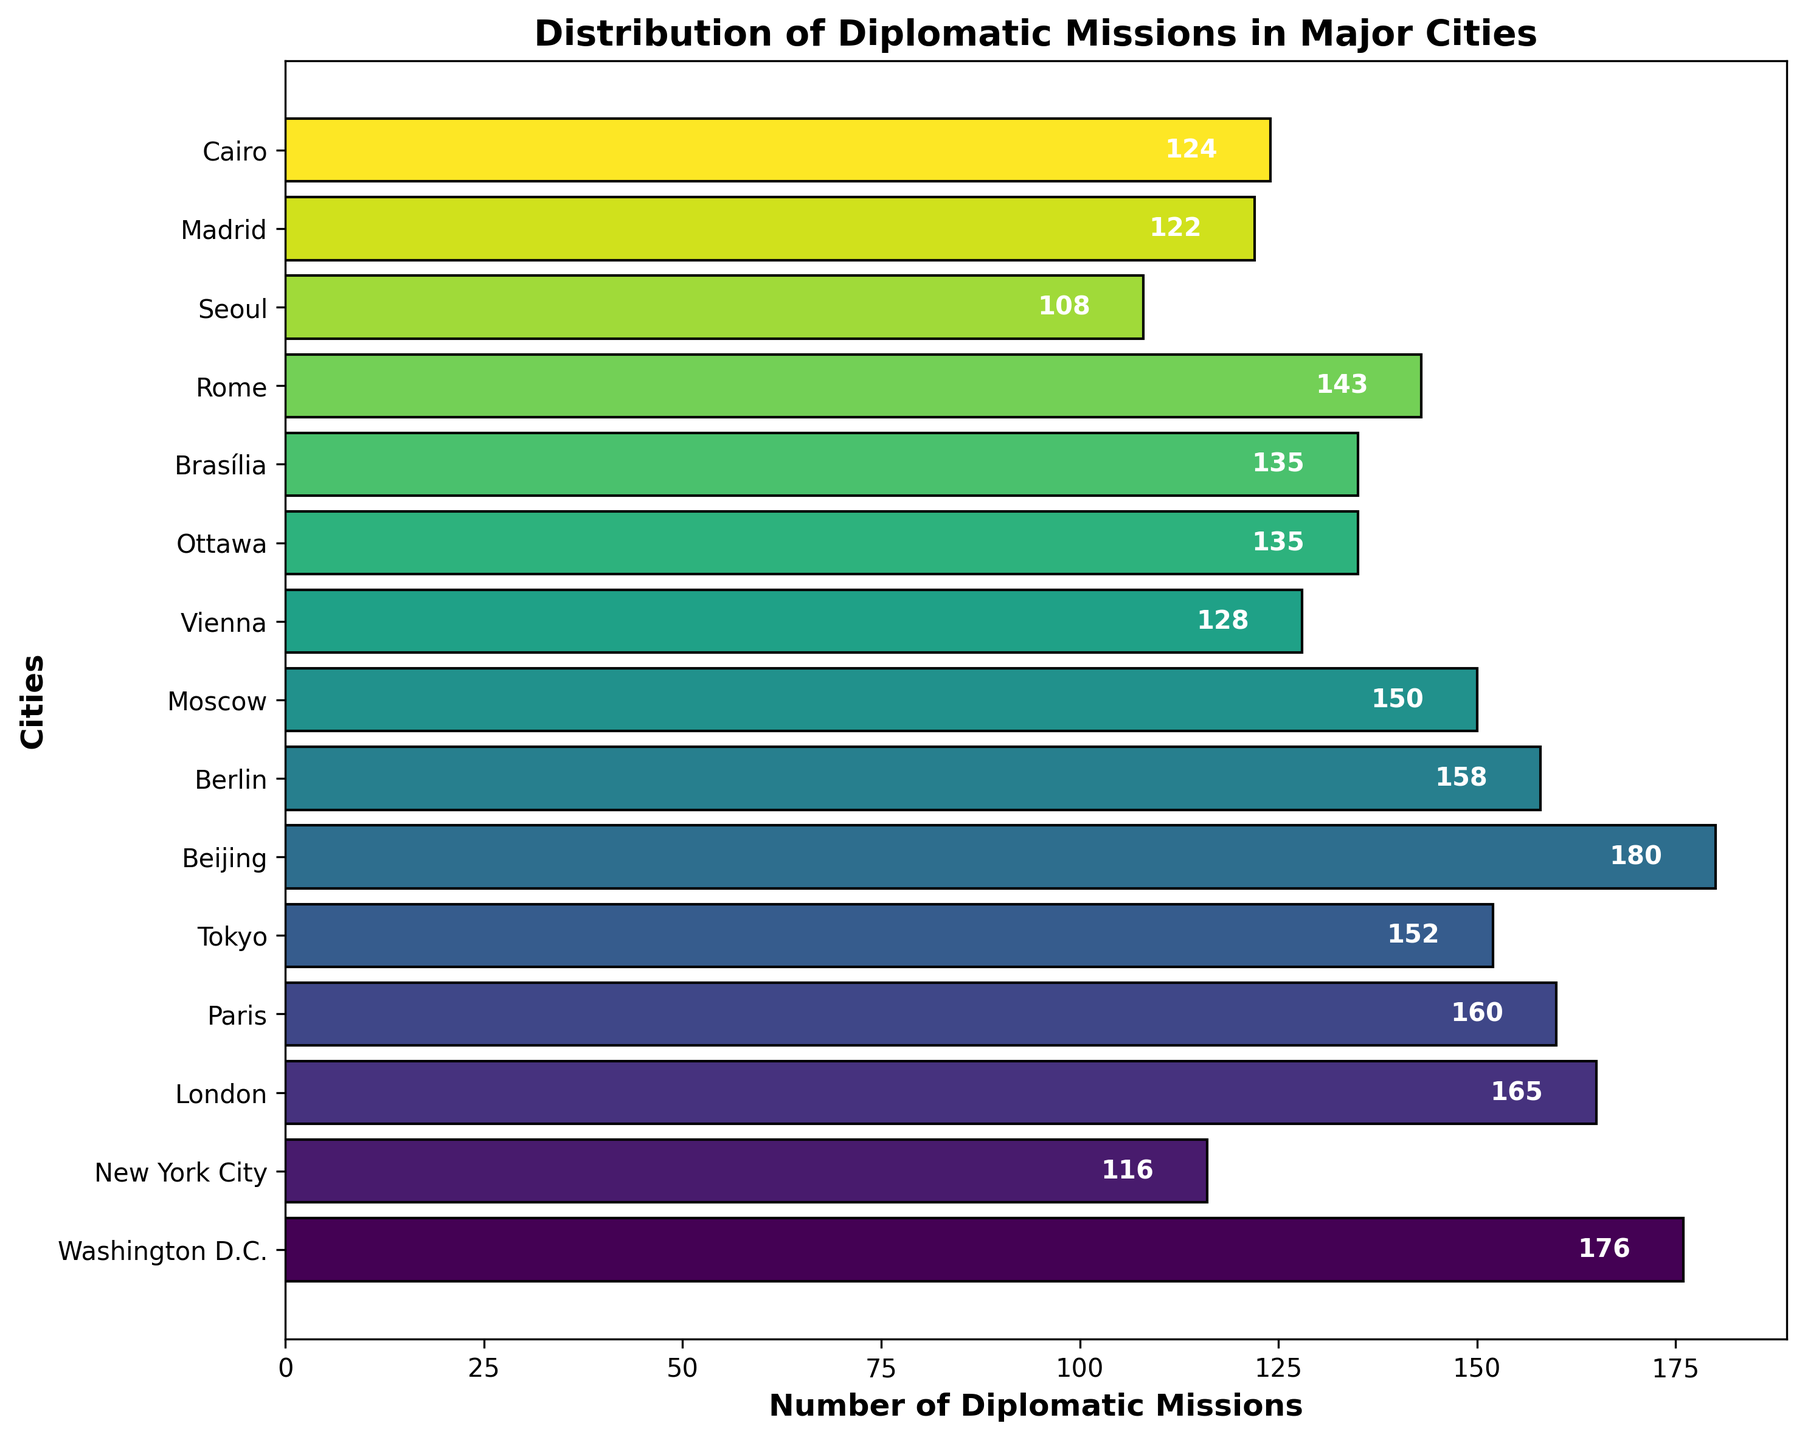Which city has the highest number of diplomatic missions? Look for the city with the tallest bar or the highest number in the text above the bars. Beijing has the tallest bar with 180 missions.
Answer: Beijing Which city has the lowest number of diplomatic missions? Look for the city with the shortest bar or the lowest number in the text above the bars. Seoul has the shortest bar with 108 missions.
Answer: Seoul What is the total number of diplomatic missions in Washington D.C., New York City, and London combined? Find the number of missions for each city: Washington D.C. (176), New York City (116), and London (165). Sum them up: 176 + 116 + 165 = 457.
Answer: 457 How many more diplomatic missions are there in Beijing compared to Moscow? Find the number of missions in each city: Beijing (180) and Moscow (150). Subtract Moscow's value from Beijing's: 180 - 150 = 30.
Answer: 30 Which city has more diplomatic missions, Vienna or Madrid, and by how much more? Find the number of missions for each city: Vienna (128) and Madrid (122). Subtract Madrid's value from Vienna's: 128 - 122 = 6.
Answer: Vienna, 6 What is the average number of diplomatic missions in the cities listed? Sum the number of missions for all cities and divide by the number of cities: (176 + 116 + 165 + 160 + 152 + 180 + 158 + 150 + 128 + 135 + 135 + 143 + 108 + 122 + 124) / 15. This totals 2052 missions across 15 cities, so the average is 2052 / 15 ≈ 136.8.
Answer: ≈136.8 How many cities have more than 150 diplomatic missions? Identify the cities with more than 150 missions: Washington D.C. (176), London (165), Paris (160), Tokyo (152), Beijing (180), and Berlin (158). This is a total of 6 cities.
Answer: 6 Which city has fewer diplomatic missions, Ottawa or Cairo, and by how much fewer? Find the number of missions for each city: Ottawa (135) and Cairo (124). Subtract Cairo's value from Ottawa's: 135 - 124 = 11.
Answer: Cairo, 11 Which cities have exactly the same number of diplomatic missions? Identify cities with the same number of missions: Ottawa and Brasília both have 135 missions.
Answer: Ottawa and Brasília What is the difference in the number of diplomatic missions between the city with the most and the city with the least number of missions? Identify the city with the most missions (Beijing, 180) and the city with the least missions (Seoul, 108). Subtract the missions of Seoul from Beijing: 180 - 108 = 72.
Answer: 72 